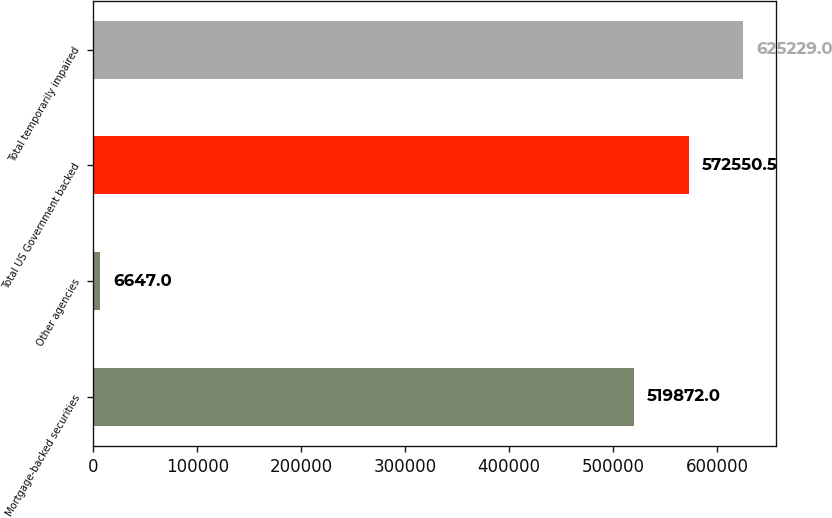<chart> <loc_0><loc_0><loc_500><loc_500><bar_chart><fcel>Mortgage-backed securities<fcel>Other agencies<fcel>Total US Government backed<fcel>Total temporarily impaired<nl><fcel>519872<fcel>6647<fcel>572550<fcel>625229<nl></chart> 